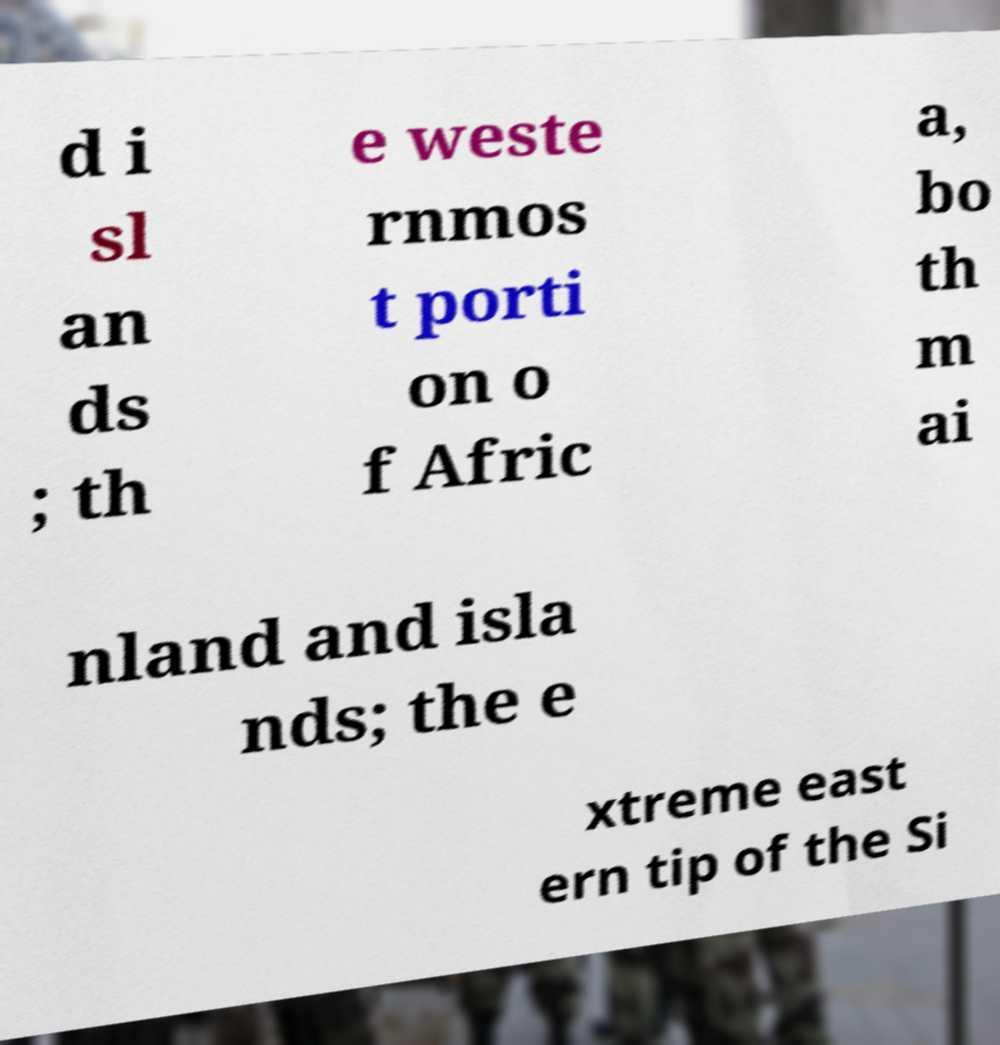Please read and relay the text visible in this image. What does it say? d i sl an ds ; th e weste rnmos t porti on o f Afric a, bo th m ai nland and isla nds; the e xtreme east ern tip of the Si 